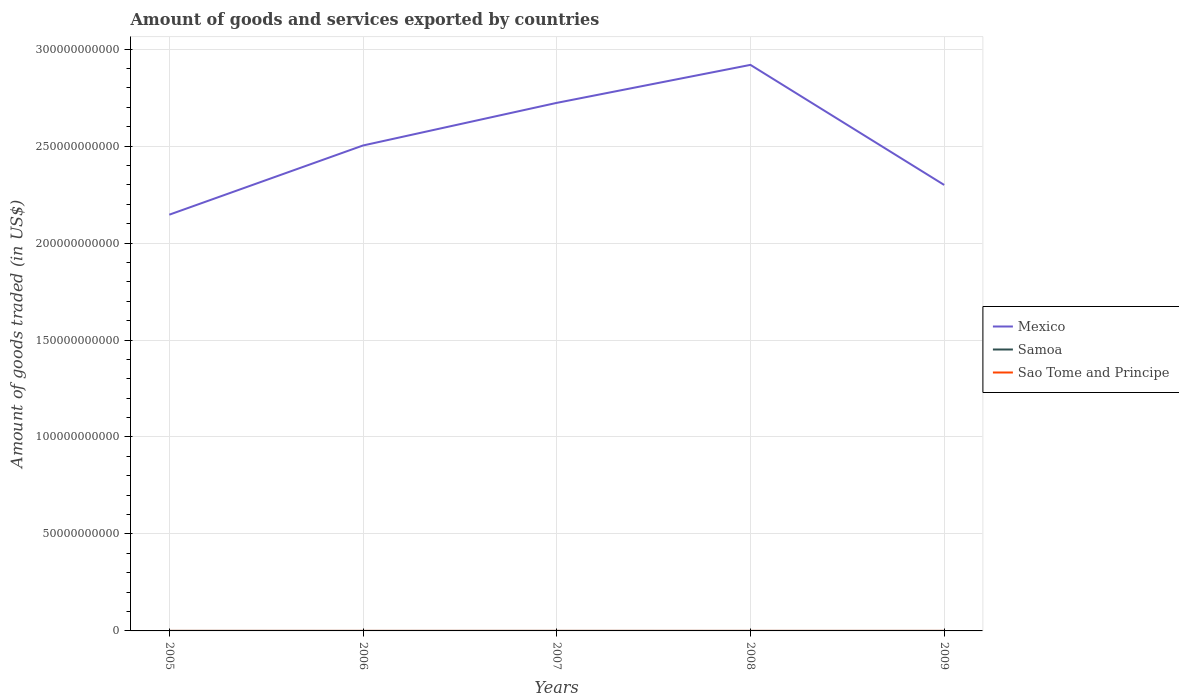How many different coloured lines are there?
Your answer should be very brief. 3. Does the line corresponding to Sao Tome and Principe intersect with the line corresponding to Mexico?
Make the answer very short. No. Is the number of lines equal to the number of legend labels?
Offer a very short reply. Yes. Across all years, what is the maximum total amount of goods and services exported in Samoa?
Make the answer very short. 1.03e+07. In which year was the total amount of goods and services exported in Sao Tome and Principe maximum?
Offer a terse response. 2005. What is the total total amount of goods and services exported in Samoa in the graph?
Ensure brevity in your answer.  2.63e+06. What is the difference between the highest and the second highest total amount of goods and services exported in Sao Tome and Principe?
Your response must be concise. 2.42e+06. Is the total amount of goods and services exported in Sao Tome and Principe strictly greater than the total amount of goods and services exported in Mexico over the years?
Provide a short and direct response. Yes. How many years are there in the graph?
Make the answer very short. 5. Are the values on the major ticks of Y-axis written in scientific E-notation?
Make the answer very short. No. Does the graph contain any zero values?
Provide a succinct answer. No. Does the graph contain grids?
Provide a short and direct response. Yes. Where does the legend appear in the graph?
Offer a very short reply. Center right. How many legend labels are there?
Ensure brevity in your answer.  3. What is the title of the graph?
Provide a succinct answer. Amount of goods and services exported by countries. What is the label or title of the Y-axis?
Give a very brief answer. Amount of goods traded (in US$). What is the Amount of goods traded (in US$) in Mexico in 2005?
Offer a very short reply. 2.15e+11. What is the Amount of goods traded (in US$) in Samoa in 2005?
Your response must be concise. 1.20e+07. What is the Amount of goods traded (in US$) in Sao Tome and Principe in 2005?
Make the answer very short. 6.79e+06. What is the Amount of goods traded (in US$) in Mexico in 2006?
Your response must be concise. 2.50e+11. What is the Amount of goods traded (in US$) of Samoa in 2006?
Offer a very short reply. 1.03e+07. What is the Amount of goods traded (in US$) in Sao Tome and Principe in 2006?
Offer a terse response. 7.71e+06. What is the Amount of goods traded (in US$) in Mexico in 2007?
Offer a very short reply. 2.72e+11. What is the Amount of goods traded (in US$) of Samoa in 2007?
Offer a terse response. 1.39e+07. What is the Amount of goods traded (in US$) in Sao Tome and Principe in 2007?
Offer a very short reply. 6.81e+06. What is the Amount of goods traded (in US$) of Mexico in 2008?
Give a very brief answer. 2.92e+11. What is the Amount of goods traded (in US$) in Samoa in 2008?
Provide a succinct answer. 1.13e+07. What is the Amount of goods traded (in US$) in Sao Tome and Principe in 2008?
Ensure brevity in your answer.  7.83e+06. What is the Amount of goods traded (in US$) of Mexico in 2009?
Your answer should be very brief. 2.30e+11. What is the Amount of goods traded (in US$) in Samoa in 2009?
Give a very brief answer. 1.16e+07. What is the Amount of goods traded (in US$) in Sao Tome and Principe in 2009?
Offer a very short reply. 9.21e+06. Across all years, what is the maximum Amount of goods traded (in US$) of Mexico?
Make the answer very short. 2.92e+11. Across all years, what is the maximum Amount of goods traded (in US$) of Samoa?
Your answer should be very brief. 1.39e+07. Across all years, what is the maximum Amount of goods traded (in US$) in Sao Tome and Principe?
Your response must be concise. 9.21e+06. Across all years, what is the minimum Amount of goods traded (in US$) in Mexico?
Your answer should be compact. 2.15e+11. Across all years, what is the minimum Amount of goods traded (in US$) of Samoa?
Your answer should be very brief. 1.03e+07. Across all years, what is the minimum Amount of goods traded (in US$) of Sao Tome and Principe?
Make the answer very short. 6.79e+06. What is the total Amount of goods traded (in US$) of Mexico in the graph?
Provide a succinct answer. 1.26e+12. What is the total Amount of goods traded (in US$) in Samoa in the graph?
Provide a succinct answer. 5.90e+07. What is the total Amount of goods traded (in US$) of Sao Tome and Principe in the graph?
Your answer should be compact. 3.83e+07. What is the difference between the Amount of goods traded (in US$) of Mexico in 2005 and that in 2006?
Your response must be concise. -3.57e+1. What is the difference between the Amount of goods traded (in US$) in Samoa in 2005 and that in 2006?
Your answer should be compact. 1.65e+06. What is the difference between the Amount of goods traded (in US$) in Sao Tome and Principe in 2005 and that in 2006?
Offer a terse response. -9.20e+05. What is the difference between the Amount of goods traded (in US$) of Mexico in 2005 and that in 2007?
Offer a terse response. -5.77e+1. What is the difference between the Amount of goods traded (in US$) in Samoa in 2005 and that in 2007?
Offer a terse response. -1.89e+06. What is the difference between the Amount of goods traded (in US$) of Sao Tome and Principe in 2005 and that in 2007?
Offer a terse response. -1.96e+04. What is the difference between the Amount of goods traded (in US$) of Mexico in 2005 and that in 2008?
Offer a terse response. -7.73e+1. What is the difference between the Amount of goods traded (in US$) in Samoa in 2005 and that in 2008?
Provide a succinct answer. 7.41e+05. What is the difference between the Amount of goods traded (in US$) of Sao Tome and Principe in 2005 and that in 2008?
Offer a very short reply. -1.04e+06. What is the difference between the Amount of goods traded (in US$) of Mexico in 2005 and that in 2009?
Provide a short and direct response. -1.53e+1. What is the difference between the Amount of goods traded (in US$) of Samoa in 2005 and that in 2009?
Keep it short and to the point. 4.46e+05. What is the difference between the Amount of goods traded (in US$) in Sao Tome and Principe in 2005 and that in 2009?
Offer a terse response. -2.42e+06. What is the difference between the Amount of goods traded (in US$) in Mexico in 2006 and that in 2007?
Ensure brevity in your answer.  -2.20e+1. What is the difference between the Amount of goods traded (in US$) of Samoa in 2006 and that in 2007?
Ensure brevity in your answer.  -3.54e+06. What is the difference between the Amount of goods traded (in US$) in Sao Tome and Principe in 2006 and that in 2007?
Provide a short and direct response. 9.00e+05. What is the difference between the Amount of goods traded (in US$) in Mexico in 2006 and that in 2008?
Provide a succinct answer. -4.16e+1. What is the difference between the Amount of goods traded (in US$) in Samoa in 2006 and that in 2008?
Keep it short and to the point. -9.10e+05. What is the difference between the Amount of goods traded (in US$) of Sao Tome and Principe in 2006 and that in 2008?
Make the answer very short. -1.21e+05. What is the difference between the Amount of goods traded (in US$) in Mexico in 2006 and that in 2009?
Your response must be concise. 2.03e+1. What is the difference between the Amount of goods traded (in US$) of Samoa in 2006 and that in 2009?
Provide a succinct answer. -1.21e+06. What is the difference between the Amount of goods traded (in US$) in Sao Tome and Principe in 2006 and that in 2009?
Provide a short and direct response. -1.50e+06. What is the difference between the Amount of goods traded (in US$) of Mexico in 2007 and that in 2008?
Give a very brief answer. -1.96e+1. What is the difference between the Amount of goods traded (in US$) of Samoa in 2007 and that in 2008?
Ensure brevity in your answer.  2.63e+06. What is the difference between the Amount of goods traded (in US$) in Sao Tome and Principe in 2007 and that in 2008?
Your answer should be compact. -1.02e+06. What is the difference between the Amount of goods traded (in US$) in Mexico in 2007 and that in 2009?
Offer a very short reply. 4.23e+1. What is the difference between the Amount of goods traded (in US$) of Samoa in 2007 and that in 2009?
Offer a very short reply. 2.34e+06. What is the difference between the Amount of goods traded (in US$) of Sao Tome and Principe in 2007 and that in 2009?
Provide a succinct answer. -2.40e+06. What is the difference between the Amount of goods traded (in US$) in Mexico in 2008 and that in 2009?
Offer a terse response. 6.19e+1. What is the difference between the Amount of goods traded (in US$) of Samoa in 2008 and that in 2009?
Your response must be concise. -2.95e+05. What is the difference between the Amount of goods traded (in US$) in Sao Tome and Principe in 2008 and that in 2009?
Your answer should be very brief. -1.37e+06. What is the difference between the Amount of goods traded (in US$) in Mexico in 2005 and the Amount of goods traded (in US$) in Samoa in 2006?
Your response must be concise. 2.15e+11. What is the difference between the Amount of goods traded (in US$) in Mexico in 2005 and the Amount of goods traded (in US$) in Sao Tome and Principe in 2006?
Offer a very short reply. 2.15e+11. What is the difference between the Amount of goods traded (in US$) in Samoa in 2005 and the Amount of goods traded (in US$) in Sao Tome and Principe in 2006?
Offer a very short reply. 4.29e+06. What is the difference between the Amount of goods traded (in US$) in Mexico in 2005 and the Amount of goods traded (in US$) in Samoa in 2007?
Give a very brief answer. 2.15e+11. What is the difference between the Amount of goods traded (in US$) of Mexico in 2005 and the Amount of goods traded (in US$) of Sao Tome and Principe in 2007?
Offer a terse response. 2.15e+11. What is the difference between the Amount of goods traded (in US$) of Samoa in 2005 and the Amount of goods traded (in US$) of Sao Tome and Principe in 2007?
Give a very brief answer. 5.19e+06. What is the difference between the Amount of goods traded (in US$) of Mexico in 2005 and the Amount of goods traded (in US$) of Samoa in 2008?
Provide a short and direct response. 2.15e+11. What is the difference between the Amount of goods traded (in US$) in Mexico in 2005 and the Amount of goods traded (in US$) in Sao Tome and Principe in 2008?
Offer a terse response. 2.15e+11. What is the difference between the Amount of goods traded (in US$) of Samoa in 2005 and the Amount of goods traded (in US$) of Sao Tome and Principe in 2008?
Your answer should be compact. 4.17e+06. What is the difference between the Amount of goods traded (in US$) of Mexico in 2005 and the Amount of goods traded (in US$) of Samoa in 2009?
Provide a succinct answer. 2.15e+11. What is the difference between the Amount of goods traded (in US$) of Mexico in 2005 and the Amount of goods traded (in US$) of Sao Tome and Principe in 2009?
Make the answer very short. 2.15e+11. What is the difference between the Amount of goods traded (in US$) in Samoa in 2005 and the Amount of goods traded (in US$) in Sao Tome and Principe in 2009?
Provide a succinct answer. 2.79e+06. What is the difference between the Amount of goods traded (in US$) of Mexico in 2006 and the Amount of goods traded (in US$) of Samoa in 2007?
Ensure brevity in your answer.  2.50e+11. What is the difference between the Amount of goods traded (in US$) in Mexico in 2006 and the Amount of goods traded (in US$) in Sao Tome and Principe in 2007?
Ensure brevity in your answer.  2.50e+11. What is the difference between the Amount of goods traded (in US$) of Samoa in 2006 and the Amount of goods traded (in US$) of Sao Tome and Principe in 2007?
Provide a short and direct response. 3.53e+06. What is the difference between the Amount of goods traded (in US$) in Mexico in 2006 and the Amount of goods traded (in US$) in Samoa in 2008?
Provide a succinct answer. 2.50e+11. What is the difference between the Amount of goods traded (in US$) of Mexico in 2006 and the Amount of goods traded (in US$) of Sao Tome and Principe in 2008?
Keep it short and to the point. 2.50e+11. What is the difference between the Amount of goods traded (in US$) of Samoa in 2006 and the Amount of goods traded (in US$) of Sao Tome and Principe in 2008?
Offer a very short reply. 2.51e+06. What is the difference between the Amount of goods traded (in US$) of Mexico in 2006 and the Amount of goods traded (in US$) of Samoa in 2009?
Keep it short and to the point. 2.50e+11. What is the difference between the Amount of goods traded (in US$) in Mexico in 2006 and the Amount of goods traded (in US$) in Sao Tome and Principe in 2009?
Your response must be concise. 2.50e+11. What is the difference between the Amount of goods traded (in US$) in Samoa in 2006 and the Amount of goods traded (in US$) in Sao Tome and Principe in 2009?
Ensure brevity in your answer.  1.14e+06. What is the difference between the Amount of goods traded (in US$) in Mexico in 2007 and the Amount of goods traded (in US$) in Samoa in 2008?
Your answer should be compact. 2.72e+11. What is the difference between the Amount of goods traded (in US$) of Mexico in 2007 and the Amount of goods traded (in US$) of Sao Tome and Principe in 2008?
Make the answer very short. 2.72e+11. What is the difference between the Amount of goods traded (in US$) of Samoa in 2007 and the Amount of goods traded (in US$) of Sao Tome and Principe in 2008?
Provide a short and direct response. 6.06e+06. What is the difference between the Amount of goods traded (in US$) of Mexico in 2007 and the Amount of goods traded (in US$) of Samoa in 2009?
Provide a short and direct response. 2.72e+11. What is the difference between the Amount of goods traded (in US$) of Mexico in 2007 and the Amount of goods traded (in US$) of Sao Tome and Principe in 2009?
Offer a very short reply. 2.72e+11. What is the difference between the Amount of goods traded (in US$) of Samoa in 2007 and the Amount of goods traded (in US$) of Sao Tome and Principe in 2009?
Offer a very short reply. 4.68e+06. What is the difference between the Amount of goods traded (in US$) in Mexico in 2008 and the Amount of goods traded (in US$) in Samoa in 2009?
Provide a short and direct response. 2.92e+11. What is the difference between the Amount of goods traded (in US$) of Mexico in 2008 and the Amount of goods traded (in US$) of Sao Tome and Principe in 2009?
Your answer should be very brief. 2.92e+11. What is the difference between the Amount of goods traded (in US$) in Samoa in 2008 and the Amount of goods traded (in US$) in Sao Tome and Principe in 2009?
Offer a very short reply. 2.05e+06. What is the average Amount of goods traded (in US$) of Mexico per year?
Your response must be concise. 2.52e+11. What is the average Amount of goods traded (in US$) in Samoa per year?
Provide a short and direct response. 1.18e+07. What is the average Amount of goods traded (in US$) of Sao Tome and Principe per year?
Ensure brevity in your answer.  7.67e+06. In the year 2005, what is the difference between the Amount of goods traded (in US$) in Mexico and Amount of goods traded (in US$) in Samoa?
Your answer should be compact. 2.15e+11. In the year 2005, what is the difference between the Amount of goods traded (in US$) of Mexico and Amount of goods traded (in US$) of Sao Tome and Principe?
Your answer should be compact. 2.15e+11. In the year 2005, what is the difference between the Amount of goods traded (in US$) of Samoa and Amount of goods traded (in US$) of Sao Tome and Principe?
Keep it short and to the point. 5.21e+06. In the year 2006, what is the difference between the Amount of goods traded (in US$) in Mexico and Amount of goods traded (in US$) in Samoa?
Make the answer very short. 2.50e+11. In the year 2006, what is the difference between the Amount of goods traded (in US$) in Mexico and Amount of goods traded (in US$) in Sao Tome and Principe?
Make the answer very short. 2.50e+11. In the year 2006, what is the difference between the Amount of goods traded (in US$) in Samoa and Amount of goods traded (in US$) in Sao Tome and Principe?
Your answer should be very brief. 2.63e+06. In the year 2007, what is the difference between the Amount of goods traded (in US$) in Mexico and Amount of goods traded (in US$) in Samoa?
Keep it short and to the point. 2.72e+11. In the year 2007, what is the difference between the Amount of goods traded (in US$) in Mexico and Amount of goods traded (in US$) in Sao Tome and Principe?
Offer a very short reply. 2.72e+11. In the year 2007, what is the difference between the Amount of goods traded (in US$) in Samoa and Amount of goods traded (in US$) in Sao Tome and Principe?
Ensure brevity in your answer.  7.08e+06. In the year 2008, what is the difference between the Amount of goods traded (in US$) of Mexico and Amount of goods traded (in US$) of Samoa?
Offer a terse response. 2.92e+11. In the year 2008, what is the difference between the Amount of goods traded (in US$) in Mexico and Amount of goods traded (in US$) in Sao Tome and Principe?
Offer a very short reply. 2.92e+11. In the year 2008, what is the difference between the Amount of goods traded (in US$) of Samoa and Amount of goods traded (in US$) of Sao Tome and Principe?
Your answer should be very brief. 3.42e+06. In the year 2009, what is the difference between the Amount of goods traded (in US$) in Mexico and Amount of goods traded (in US$) in Samoa?
Your answer should be compact. 2.30e+11. In the year 2009, what is the difference between the Amount of goods traded (in US$) of Mexico and Amount of goods traded (in US$) of Sao Tome and Principe?
Make the answer very short. 2.30e+11. In the year 2009, what is the difference between the Amount of goods traded (in US$) of Samoa and Amount of goods traded (in US$) of Sao Tome and Principe?
Provide a succinct answer. 2.34e+06. What is the ratio of the Amount of goods traded (in US$) in Mexico in 2005 to that in 2006?
Your answer should be very brief. 0.86. What is the ratio of the Amount of goods traded (in US$) of Samoa in 2005 to that in 2006?
Offer a terse response. 1.16. What is the ratio of the Amount of goods traded (in US$) in Sao Tome and Principe in 2005 to that in 2006?
Your response must be concise. 0.88. What is the ratio of the Amount of goods traded (in US$) of Mexico in 2005 to that in 2007?
Keep it short and to the point. 0.79. What is the ratio of the Amount of goods traded (in US$) of Samoa in 2005 to that in 2007?
Your answer should be compact. 0.86. What is the ratio of the Amount of goods traded (in US$) in Mexico in 2005 to that in 2008?
Give a very brief answer. 0.74. What is the ratio of the Amount of goods traded (in US$) in Samoa in 2005 to that in 2008?
Ensure brevity in your answer.  1.07. What is the ratio of the Amount of goods traded (in US$) in Sao Tome and Principe in 2005 to that in 2008?
Your response must be concise. 0.87. What is the ratio of the Amount of goods traded (in US$) of Mexico in 2005 to that in 2009?
Provide a succinct answer. 0.93. What is the ratio of the Amount of goods traded (in US$) of Samoa in 2005 to that in 2009?
Your response must be concise. 1.04. What is the ratio of the Amount of goods traded (in US$) in Sao Tome and Principe in 2005 to that in 2009?
Provide a succinct answer. 0.74. What is the ratio of the Amount of goods traded (in US$) in Mexico in 2006 to that in 2007?
Your response must be concise. 0.92. What is the ratio of the Amount of goods traded (in US$) of Samoa in 2006 to that in 2007?
Your answer should be very brief. 0.74. What is the ratio of the Amount of goods traded (in US$) of Sao Tome and Principe in 2006 to that in 2007?
Make the answer very short. 1.13. What is the ratio of the Amount of goods traded (in US$) of Mexico in 2006 to that in 2008?
Make the answer very short. 0.86. What is the ratio of the Amount of goods traded (in US$) of Samoa in 2006 to that in 2008?
Offer a very short reply. 0.92. What is the ratio of the Amount of goods traded (in US$) in Sao Tome and Principe in 2006 to that in 2008?
Ensure brevity in your answer.  0.98. What is the ratio of the Amount of goods traded (in US$) of Mexico in 2006 to that in 2009?
Make the answer very short. 1.09. What is the ratio of the Amount of goods traded (in US$) of Samoa in 2006 to that in 2009?
Keep it short and to the point. 0.9. What is the ratio of the Amount of goods traded (in US$) in Sao Tome and Principe in 2006 to that in 2009?
Keep it short and to the point. 0.84. What is the ratio of the Amount of goods traded (in US$) of Mexico in 2007 to that in 2008?
Make the answer very short. 0.93. What is the ratio of the Amount of goods traded (in US$) of Samoa in 2007 to that in 2008?
Ensure brevity in your answer.  1.23. What is the ratio of the Amount of goods traded (in US$) in Sao Tome and Principe in 2007 to that in 2008?
Make the answer very short. 0.87. What is the ratio of the Amount of goods traded (in US$) in Mexico in 2007 to that in 2009?
Offer a terse response. 1.18. What is the ratio of the Amount of goods traded (in US$) in Samoa in 2007 to that in 2009?
Ensure brevity in your answer.  1.2. What is the ratio of the Amount of goods traded (in US$) in Sao Tome and Principe in 2007 to that in 2009?
Your answer should be compact. 0.74. What is the ratio of the Amount of goods traded (in US$) of Mexico in 2008 to that in 2009?
Provide a short and direct response. 1.27. What is the ratio of the Amount of goods traded (in US$) of Samoa in 2008 to that in 2009?
Ensure brevity in your answer.  0.97. What is the ratio of the Amount of goods traded (in US$) of Sao Tome and Principe in 2008 to that in 2009?
Provide a succinct answer. 0.85. What is the difference between the highest and the second highest Amount of goods traded (in US$) of Mexico?
Your response must be concise. 1.96e+1. What is the difference between the highest and the second highest Amount of goods traded (in US$) in Samoa?
Make the answer very short. 1.89e+06. What is the difference between the highest and the second highest Amount of goods traded (in US$) in Sao Tome and Principe?
Keep it short and to the point. 1.37e+06. What is the difference between the highest and the lowest Amount of goods traded (in US$) in Mexico?
Keep it short and to the point. 7.73e+1. What is the difference between the highest and the lowest Amount of goods traded (in US$) of Samoa?
Provide a succinct answer. 3.54e+06. What is the difference between the highest and the lowest Amount of goods traded (in US$) in Sao Tome and Principe?
Offer a very short reply. 2.42e+06. 